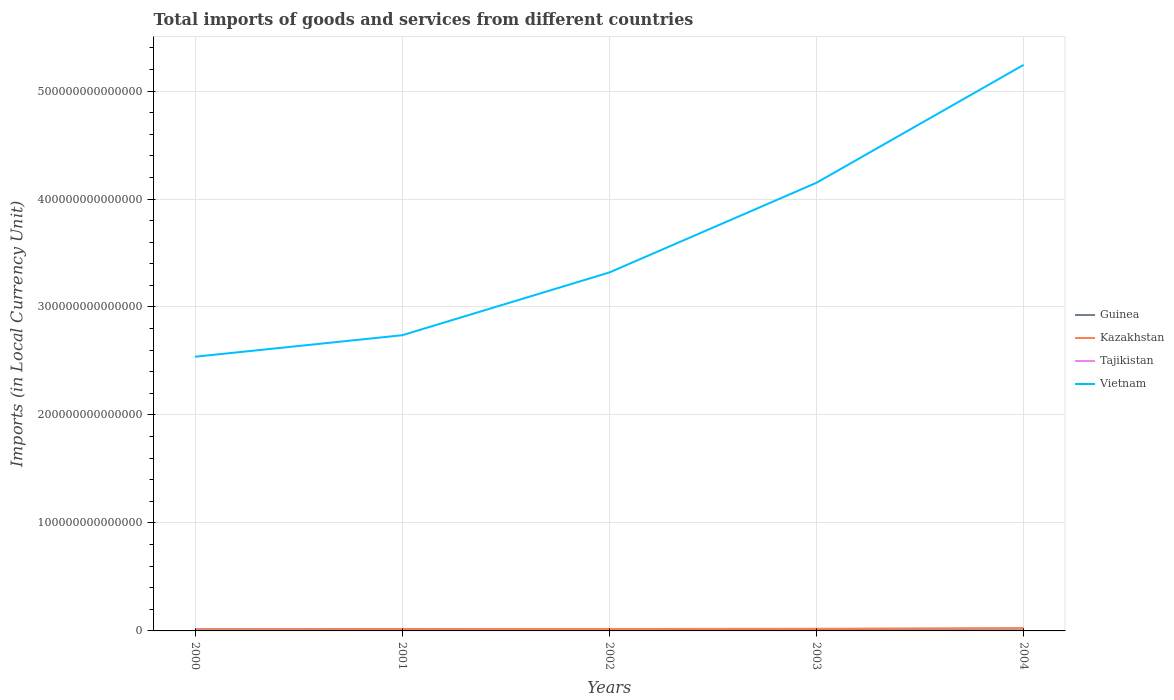How many different coloured lines are there?
Give a very brief answer. 4. Does the line corresponding to Guinea intersect with the line corresponding to Tajikistan?
Give a very brief answer. No. Is the number of lines equal to the number of legend labels?
Offer a terse response. Yes. Across all years, what is the maximum Amount of goods and services imports in Vietnam?
Provide a succinct answer. 2.54e+14. What is the total Amount of goods and services imports in Guinea in the graph?
Give a very brief answer. -4.17e+11. What is the difference between the highest and the second highest Amount of goods and services imports in Tajikistan?
Offer a terse response. 2.51e+09. What is the difference between the highest and the lowest Amount of goods and services imports in Tajikistan?
Your answer should be compact. 2. Is the Amount of goods and services imports in Kazakhstan strictly greater than the Amount of goods and services imports in Tajikistan over the years?
Your response must be concise. No. How many lines are there?
Offer a very short reply. 4. How many years are there in the graph?
Your response must be concise. 5. What is the difference between two consecutive major ticks on the Y-axis?
Keep it short and to the point. 1.00e+14. Where does the legend appear in the graph?
Offer a terse response. Center right. What is the title of the graph?
Offer a terse response. Total imports of goods and services from different countries. Does "Bulgaria" appear as one of the legend labels in the graph?
Offer a terse response. No. What is the label or title of the Y-axis?
Offer a very short reply. Imports (in Local Currency Unit). What is the Imports (in Local Currency Unit) in Guinea in 2000?
Your answer should be very brief. 1.52e+12. What is the Imports (in Local Currency Unit) in Kazakhstan in 2000?
Your answer should be compact. 1.28e+12. What is the Imports (in Local Currency Unit) of Tajikistan in 2000?
Ensure brevity in your answer.  1.80e+09. What is the Imports (in Local Currency Unit) in Vietnam in 2000?
Your response must be concise. 2.54e+14. What is the Imports (in Local Currency Unit) of Guinea in 2001?
Make the answer very short. 1.66e+12. What is the Imports (in Local Currency Unit) in Kazakhstan in 2001?
Offer a terse response. 1.53e+12. What is the Imports (in Local Currency Unit) in Tajikistan in 2001?
Your answer should be compact. 2.01e+09. What is the Imports (in Local Currency Unit) of Vietnam in 2001?
Your answer should be compact. 2.74e+14. What is the Imports (in Local Currency Unit) of Guinea in 2002?
Ensure brevity in your answer.  1.69e+12. What is the Imports (in Local Currency Unit) of Kazakhstan in 2002?
Provide a short and direct response. 1.78e+12. What is the Imports (in Local Currency Unit) in Tajikistan in 2002?
Provide a short and direct response. 2.57e+09. What is the Imports (in Local Currency Unit) of Vietnam in 2002?
Provide a short and direct response. 3.32e+14. What is the Imports (in Local Currency Unit) in Guinea in 2003?
Keep it short and to the point. 1.72e+12. What is the Imports (in Local Currency Unit) in Kazakhstan in 2003?
Offer a very short reply. 1.99e+12. What is the Imports (in Local Currency Unit) of Tajikistan in 2003?
Make the answer very short. 3.50e+09. What is the Imports (in Local Currency Unit) in Vietnam in 2003?
Offer a very short reply. 4.15e+14. What is the Imports (in Local Currency Unit) in Guinea in 2004?
Offer a terse response. 2.11e+12. What is the Imports (in Local Currency Unit) of Kazakhstan in 2004?
Keep it short and to the point. 2.58e+12. What is the Imports (in Local Currency Unit) in Tajikistan in 2004?
Give a very brief answer. 4.31e+09. What is the Imports (in Local Currency Unit) of Vietnam in 2004?
Make the answer very short. 5.24e+14. Across all years, what is the maximum Imports (in Local Currency Unit) in Guinea?
Provide a succinct answer. 2.11e+12. Across all years, what is the maximum Imports (in Local Currency Unit) in Kazakhstan?
Offer a terse response. 2.58e+12. Across all years, what is the maximum Imports (in Local Currency Unit) of Tajikistan?
Make the answer very short. 4.31e+09. Across all years, what is the maximum Imports (in Local Currency Unit) of Vietnam?
Offer a very short reply. 5.24e+14. Across all years, what is the minimum Imports (in Local Currency Unit) of Guinea?
Your answer should be compact. 1.52e+12. Across all years, what is the minimum Imports (in Local Currency Unit) in Kazakhstan?
Ensure brevity in your answer.  1.28e+12. Across all years, what is the minimum Imports (in Local Currency Unit) of Tajikistan?
Offer a terse response. 1.80e+09. Across all years, what is the minimum Imports (in Local Currency Unit) in Vietnam?
Offer a terse response. 2.54e+14. What is the total Imports (in Local Currency Unit) in Guinea in the graph?
Your answer should be compact. 8.69e+12. What is the total Imports (in Local Currency Unit) in Kazakhstan in the graph?
Give a very brief answer. 9.14e+12. What is the total Imports (in Local Currency Unit) of Tajikistan in the graph?
Offer a terse response. 1.42e+1. What is the total Imports (in Local Currency Unit) in Vietnam in the graph?
Offer a very short reply. 1.80e+15. What is the difference between the Imports (in Local Currency Unit) in Guinea in 2000 and that in 2001?
Your answer should be compact. -1.41e+11. What is the difference between the Imports (in Local Currency Unit) in Kazakhstan in 2000 and that in 2001?
Offer a very short reply. -2.50e+11. What is the difference between the Imports (in Local Currency Unit) of Tajikistan in 2000 and that in 2001?
Your answer should be compact. -2.06e+08. What is the difference between the Imports (in Local Currency Unit) of Vietnam in 2000 and that in 2001?
Offer a terse response. -1.99e+13. What is the difference between the Imports (in Local Currency Unit) of Guinea in 2000 and that in 2002?
Make the answer very short. -1.74e+11. What is the difference between the Imports (in Local Currency Unit) of Kazakhstan in 2000 and that in 2002?
Offer a very short reply. -5.00e+11. What is the difference between the Imports (in Local Currency Unit) of Tajikistan in 2000 and that in 2002?
Make the answer very short. -7.65e+08. What is the difference between the Imports (in Local Currency Unit) of Vietnam in 2000 and that in 2002?
Offer a terse response. -7.80e+13. What is the difference between the Imports (in Local Currency Unit) of Guinea in 2000 and that in 2003?
Offer a terse response. -2.08e+11. What is the difference between the Imports (in Local Currency Unit) in Kazakhstan in 2000 and that in 2003?
Give a very brief answer. -7.09e+11. What is the difference between the Imports (in Local Currency Unit) in Tajikistan in 2000 and that in 2003?
Keep it short and to the point. -1.69e+09. What is the difference between the Imports (in Local Currency Unit) of Vietnam in 2000 and that in 2003?
Keep it short and to the point. -1.61e+14. What is the difference between the Imports (in Local Currency Unit) of Guinea in 2000 and that in 2004?
Provide a short and direct response. -5.91e+11. What is the difference between the Imports (in Local Currency Unit) in Kazakhstan in 2000 and that in 2004?
Your answer should be very brief. -1.30e+12. What is the difference between the Imports (in Local Currency Unit) of Tajikistan in 2000 and that in 2004?
Make the answer very short. -2.51e+09. What is the difference between the Imports (in Local Currency Unit) of Vietnam in 2000 and that in 2004?
Make the answer very short. -2.70e+14. What is the difference between the Imports (in Local Currency Unit) of Guinea in 2001 and that in 2002?
Provide a succinct answer. -3.20e+1. What is the difference between the Imports (in Local Currency Unit) of Kazakhstan in 2001 and that in 2002?
Keep it short and to the point. -2.50e+11. What is the difference between the Imports (in Local Currency Unit) in Tajikistan in 2001 and that in 2002?
Your response must be concise. -5.59e+08. What is the difference between the Imports (in Local Currency Unit) in Vietnam in 2001 and that in 2002?
Offer a terse response. -5.81e+13. What is the difference between the Imports (in Local Currency Unit) in Guinea in 2001 and that in 2003?
Keep it short and to the point. -6.62e+1. What is the difference between the Imports (in Local Currency Unit) of Kazakhstan in 2001 and that in 2003?
Ensure brevity in your answer.  -4.59e+11. What is the difference between the Imports (in Local Currency Unit) in Tajikistan in 2001 and that in 2003?
Your answer should be very brief. -1.49e+09. What is the difference between the Imports (in Local Currency Unit) of Vietnam in 2001 and that in 2003?
Make the answer very short. -1.41e+14. What is the difference between the Imports (in Local Currency Unit) of Guinea in 2001 and that in 2004?
Keep it short and to the point. -4.49e+11. What is the difference between the Imports (in Local Currency Unit) of Kazakhstan in 2001 and that in 2004?
Your answer should be compact. -1.05e+12. What is the difference between the Imports (in Local Currency Unit) in Tajikistan in 2001 and that in 2004?
Give a very brief answer. -2.30e+09. What is the difference between the Imports (in Local Currency Unit) in Vietnam in 2001 and that in 2004?
Provide a succinct answer. -2.50e+14. What is the difference between the Imports (in Local Currency Unit) of Guinea in 2002 and that in 2003?
Offer a terse response. -3.42e+1. What is the difference between the Imports (in Local Currency Unit) in Kazakhstan in 2002 and that in 2003?
Ensure brevity in your answer.  -2.09e+11. What is the difference between the Imports (in Local Currency Unit) of Tajikistan in 2002 and that in 2003?
Give a very brief answer. -9.28e+08. What is the difference between the Imports (in Local Currency Unit) of Vietnam in 2002 and that in 2003?
Your answer should be very brief. -8.31e+13. What is the difference between the Imports (in Local Currency Unit) in Guinea in 2002 and that in 2004?
Provide a short and direct response. -4.17e+11. What is the difference between the Imports (in Local Currency Unit) in Kazakhstan in 2002 and that in 2004?
Provide a short and direct response. -8.01e+11. What is the difference between the Imports (in Local Currency Unit) in Tajikistan in 2002 and that in 2004?
Make the answer very short. -1.74e+09. What is the difference between the Imports (in Local Currency Unit) of Vietnam in 2002 and that in 2004?
Ensure brevity in your answer.  -1.92e+14. What is the difference between the Imports (in Local Currency Unit) of Guinea in 2003 and that in 2004?
Offer a terse response. -3.83e+11. What is the difference between the Imports (in Local Currency Unit) in Kazakhstan in 2003 and that in 2004?
Offer a terse response. -5.92e+11. What is the difference between the Imports (in Local Currency Unit) of Tajikistan in 2003 and that in 2004?
Ensure brevity in your answer.  -8.15e+08. What is the difference between the Imports (in Local Currency Unit) in Vietnam in 2003 and that in 2004?
Provide a succinct answer. -1.09e+14. What is the difference between the Imports (in Local Currency Unit) of Guinea in 2000 and the Imports (in Local Currency Unit) of Kazakhstan in 2001?
Your answer should be very brief. -1.11e+1. What is the difference between the Imports (in Local Currency Unit) of Guinea in 2000 and the Imports (in Local Currency Unit) of Tajikistan in 2001?
Provide a succinct answer. 1.51e+12. What is the difference between the Imports (in Local Currency Unit) in Guinea in 2000 and the Imports (in Local Currency Unit) in Vietnam in 2001?
Give a very brief answer. -2.72e+14. What is the difference between the Imports (in Local Currency Unit) in Kazakhstan in 2000 and the Imports (in Local Currency Unit) in Tajikistan in 2001?
Ensure brevity in your answer.  1.27e+12. What is the difference between the Imports (in Local Currency Unit) of Kazakhstan in 2000 and the Imports (in Local Currency Unit) of Vietnam in 2001?
Provide a short and direct response. -2.73e+14. What is the difference between the Imports (in Local Currency Unit) of Tajikistan in 2000 and the Imports (in Local Currency Unit) of Vietnam in 2001?
Give a very brief answer. -2.74e+14. What is the difference between the Imports (in Local Currency Unit) of Guinea in 2000 and the Imports (in Local Currency Unit) of Kazakhstan in 2002?
Your answer should be very brief. -2.61e+11. What is the difference between the Imports (in Local Currency Unit) of Guinea in 2000 and the Imports (in Local Currency Unit) of Tajikistan in 2002?
Your response must be concise. 1.51e+12. What is the difference between the Imports (in Local Currency Unit) in Guinea in 2000 and the Imports (in Local Currency Unit) in Vietnam in 2002?
Make the answer very short. -3.30e+14. What is the difference between the Imports (in Local Currency Unit) in Kazakhstan in 2000 and the Imports (in Local Currency Unit) in Tajikistan in 2002?
Keep it short and to the point. 1.27e+12. What is the difference between the Imports (in Local Currency Unit) in Kazakhstan in 2000 and the Imports (in Local Currency Unit) in Vietnam in 2002?
Give a very brief answer. -3.31e+14. What is the difference between the Imports (in Local Currency Unit) of Tajikistan in 2000 and the Imports (in Local Currency Unit) of Vietnam in 2002?
Provide a short and direct response. -3.32e+14. What is the difference between the Imports (in Local Currency Unit) of Guinea in 2000 and the Imports (in Local Currency Unit) of Kazakhstan in 2003?
Your answer should be very brief. -4.70e+11. What is the difference between the Imports (in Local Currency Unit) of Guinea in 2000 and the Imports (in Local Currency Unit) of Tajikistan in 2003?
Provide a short and direct response. 1.51e+12. What is the difference between the Imports (in Local Currency Unit) in Guinea in 2000 and the Imports (in Local Currency Unit) in Vietnam in 2003?
Ensure brevity in your answer.  -4.14e+14. What is the difference between the Imports (in Local Currency Unit) of Kazakhstan in 2000 and the Imports (in Local Currency Unit) of Tajikistan in 2003?
Your answer should be compact. 1.27e+12. What is the difference between the Imports (in Local Currency Unit) of Kazakhstan in 2000 and the Imports (in Local Currency Unit) of Vietnam in 2003?
Ensure brevity in your answer.  -4.14e+14. What is the difference between the Imports (in Local Currency Unit) of Tajikistan in 2000 and the Imports (in Local Currency Unit) of Vietnam in 2003?
Provide a short and direct response. -4.15e+14. What is the difference between the Imports (in Local Currency Unit) of Guinea in 2000 and the Imports (in Local Currency Unit) of Kazakhstan in 2004?
Make the answer very short. -1.06e+12. What is the difference between the Imports (in Local Currency Unit) in Guinea in 2000 and the Imports (in Local Currency Unit) in Tajikistan in 2004?
Your response must be concise. 1.51e+12. What is the difference between the Imports (in Local Currency Unit) in Guinea in 2000 and the Imports (in Local Currency Unit) in Vietnam in 2004?
Provide a succinct answer. -5.23e+14. What is the difference between the Imports (in Local Currency Unit) of Kazakhstan in 2000 and the Imports (in Local Currency Unit) of Tajikistan in 2004?
Ensure brevity in your answer.  1.27e+12. What is the difference between the Imports (in Local Currency Unit) in Kazakhstan in 2000 and the Imports (in Local Currency Unit) in Vietnam in 2004?
Your answer should be compact. -5.23e+14. What is the difference between the Imports (in Local Currency Unit) of Tajikistan in 2000 and the Imports (in Local Currency Unit) of Vietnam in 2004?
Provide a succinct answer. -5.24e+14. What is the difference between the Imports (in Local Currency Unit) of Guinea in 2001 and the Imports (in Local Currency Unit) of Kazakhstan in 2002?
Offer a very short reply. -1.20e+11. What is the difference between the Imports (in Local Currency Unit) in Guinea in 2001 and the Imports (in Local Currency Unit) in Tajikistan in 2002?
Provide a succinct answer. 1.65e+12. What is the difference between the Imports (in Local Currency Unit) of Guinea in 2001 and the Imports (in Local Currency Unit) of Vietnam in 2002?
Offer a very short reply. -3.30e+14. What is the difference between the Imports (in Local Currency Unit) of Kazakhstan in 2001 and the Imports (in Local Currency Unit) of Tajikistan in 2002?
Provide a succinct answer. 1.52e+12. What is the difference between the Imports (in Local Currency Unit) of Kazakhstan in 2001 and the Imports (in Local Currency Unit) of Vietnam in 2002?
Offer a very short reply. -3.30e+14. What is the difference between the Imports (in Local Currency Unit) in Tajikistan in 2001 and the Imports (in Local Currency Unit) in Vietnam in 2002?
Offer a terse response. -3.32e+14. What is the difference between the Imports (in Local Currency Unit) of Guinea in 2001 and the Imports (in Local Currency Unit) of Kazakhstan in 2003?
Your answer should be very brief. -3.29e+11. What is the difference between the Imports (in Local Currency Unit) of Guinea in 2001 and the Imports (in Local Currency Unit) of Tajikistan in 2003?
Your answer should be compact. 1.65e+12. What is the difference between the Imports (in Local Currency Unit) in Guinea in 2001 and the Imports (in Local Currency Unit) in Vietnam in 2003?
Ensure brevity in your answer.  -4.13e+14. What is the difference between the Imports (in Local Currency Unit) of Kazakhstan in 2001 and the Imports (in Local Currency Unit) of Tajikistan in 2003?
Offer a very short reply. 1.52e+12. What is the difference between the Imports (in Local Currency Unit) in Kazakhstan in 2001 and the Imports (in Local Currency Unit) in Vietnam in 2003?
Offer a terse response. -4.13e+14. What is the difference between the Imports (in Local Currency Unit) of Tajikistan in 2001 and the Imports (in Local Currency Unit) of Vietnam in 2003?
Offer a very short reply. -4.15e+14. What is the difference between the Imports (in Local Currency Unit) of Guinea in 2001 and the Imports (in Local Currency Unit) of Kazakhstan in 2004?
Keep it short and to the point. -9.21e+11. What is the difference between the Imports (in Local Currency Unit) of Guinea in 2001 and the Imports (in Local Currency Unit) of Tajikistan in 2004?
Make the answer very short. 1.65e+12. What is the difference between the Imports (in Local Currency Unit) of Guinea in 2001 and the Imports (in Local Currency Unit) of Vietnam in 2004?
Offer a very short reply. -5.23e+14. What is the difference between the Imports (in Local Currency Unit) of Kazakhstan in 2001 and the Imports (in Local Currency Unit) of Tajikistan in 2004?
Your answer should be very brief. 1.52e+12. What is the difference between the Imports (in Local Currency Unit) in Kazakhstan in 2001 and the Imports (in Local Currency Unit) in Vietnam in 2004?
Your response must be concise. -5.23e+14. What is the difference between the Imports (in Local Currency Unit) in Tajikistan in 2001 and the Imports (in Local Currency Unit) in Vietnam in 2004?
Your response must be concise. -5.24e+14. What is the difference between the Imports (in Local Currency Unit) in Guinea in 2002 and the Imports (in Local Currency Unit) in Kazakhstan in 2003?
Your answer should be compact. -2.97e+11. What is the difference between the Imports (in Local Currency Unit) in Guinea in 2002 and the Imports (in Local Currency Unit) in Tajikistan in 2003?
Give a very brief answer. 1.69e+12. What is the difference between the Imports (in Local Currency Unit) in Guinea in 2002 and the Imports (in Local Currency Unit) in Vietnam in 2003?
Keep it short and to the point. -4.13e+14. What is the difference between the Imports (in Local Currency Unit) in Kazakhstan in 2002 and the Imports (in Local Currency Unit) in Tajikistan in 2003?
Give a very brief answer. 1.77e+12. What is the difference between the Imports (in Local Currency Unit) of Kazakhstan in 2002 and the Imports (in Local Currency Unit) of Vietnam in 2003?
Keep it short and to the point. -4.13e+14. What is the difference between the Imports (in Local Currency Unit) of Tajikistan in 2002 and the Imports (in Local Currency Unit) of Vietnam in 2003?
Ensure brevity in your answer.  -4.15e+14. What is the difference between the Imports (in Local Currency Unit) of Guinea in 2002 and the Imports (in Local Currency Unit) of Kazakhstan in 2004?
Your answer should be very brief. -8.89e+11. What is the difference between the Imports (in Local Currency Unit) of Guinea in 2002 and the Imports (in Local Currency Unit) of Tajikistan in 2004?
Provide a succinct answer. 1.68e+12. What is the difference between the Imports (in Local Currency Unit) of Guinea in 2002 and the Imports (in Local Currency Unit) of Vietnam in 2004?
Keep it short and to the point. -5.23e+14. What is the difference between the Imports (in Local Currency Unit) in Kazakhstan in 2002 and the Imports (in Local Currency Unit) in Tajikistan in 2004?
Give a very brief answer. 1.77e+12. What is the difference between the Imports (in Local Currency Unit) of Kazakhstan in 2002 and the Imports (in Local Currency Unit) of Vietnam in 2004?
Your response must be concise. -5.22e+14. What is the difference between the Imports (in Local Currency Unit) of Tajikistan in 2002 and the Imports (in Local Currency Unit) of Vietnam in 2004?
Make the answer very short. -5.24e+14. What is the difference between the Imports (in Local Currency Unit) in Guinea in 2003 and the Imports (in Local Currency Unit) in Kazakhstan in 2004?
Offer a terse response. -8.55e+11. What is the difference between the Imports (in Local Currency Unit) in Guinea in 2003 and the Imports (in Local Currency Unit) in Tajikistan in 2004?
Your answer should be compact. 1.72e+12. What is the difference between the Imports (in Local Currency Unit) of Guinea in 2003 and the Imports (in Local Currency Unit) of Vietnam in 2004?
Ensure brevity in your answer.  -5.22e+14. What is the difference between the Imports (in Local Currency Unit) in Kazakhstan in 2003 and the Imports (in Local Currency Unit) in Tajikistan in 2004?
Offer a very short reply. 1.98e+12. What is the difference between the Imports (in Local Currency Unit) in Kazakhstan in 2003 and the Imports (in Local Currency Unit) in Vietnam in 2004?
Provide a succinct answer. -5.22e+14. What is the difference between the Imports (in Local Currency Unit) of Tajikistan in 2003 and the Imports (in Local Currency Unit) of Vietnam in 2004?
Ensure brevity in your answer.  -5.24e+14. What is the average Imports (in Local Currency Unit) in Guinea per year?
Your response must be concise. 1.74e+12. What is the average Imports (in Local Currency Unit) in Kazakhstan per year?
Give a very brief answer. 1.83e+12. What is the average Imports (in Local Currency Unit) of Tajikistan per year?
Ensure brevity in your answer.  2.84e+09. What is the average Imports (in Local Currency Unit) of Vietnam per year?
Keep it short and to the point. 3.60e+14. In the year 2000, what is the difference between the Imports (in Local Currency Unit) in Guinea and Imports (in Local Currency Unit) in Kazakhstan?
Provide a succinct answer. 2.39e+11. In the year 2000, what is the difference between the Imports (in Local Currency Unit) in Guinea and Imports (in Local Currency Unit) in Tajikistan?
Offer a terse response. 1.51e+12. In the year 2000, what is the difference between the Imports (in Local Currency Unit) of Guinea and Imports (in Local Currency Unit) of Vietnam?
Your answer should be very brief. -2.52e+14. In the year 2000, what is the difference between the Imports (in Local Currency Unit) in Kazakhstan and Imports (in Local Currency Unit) in Tajikistan?
Your answer should be very brief. 1.27e+12. In the year 2000, what is the difference between the Imports (in Local Currency Unit) of Kazakhstan and Imports (in Local Currency Unit) of Vietnam?
Your answer should be very brief. -2.53e+14. In the year 2000, what is the difference between the Imports (in Local Currency Unit) of Tajikistan and Imports (in Local Currency Unit) of Vietnam?
Offer a very short reply. -2.54e+14. In the year 2001, what is the difference between the Imports (in Local Currency Unit) of Guinea and Imports (in Local Currency Unit) of Kazakhstan?
Provide a succinct answer. 1.30e+11. In the year 2001, what is the difference between the Imports (in Local Currency Unit) in Guinea and Imports (in Local Currency Unit) in Tajikistan?
Offer a terse response. 1.65e+12. In the year 2001, what is the difference between the Imports (in Local Currency Unit) in Guinea and Imports (in Local Currency Unit) in Vietnam?
Offer a terse response. -2.72e+14. In the year 2001, what is the difference between the Imports (in Local Currency Unit) in Kazakhstan and Imports (in Local Currency Unit) in Tajikistan?
Keep it short and to the point. 1.52e+12. In the year 2001, what is the difference between the Imports (in Local Currency Unit) in Kazakhstan and Imports (in Local Currency Unit) in Vietnam?
Your answer should be compact. -2.72e+14. In the year 2001, what is the difference between the Imports (in Local Currency Unit) in Tajikistan and Imports (in Local Currency Unit) in Vietnam?
Make the answer very short. -2.74e+14. In the year 2002, what is the difference between the Imports (in Local Currency Unit) in Guinea and Imports (in Local Currency Unit) in Kazakhstan?
Keep it short and to the point. -8.77e+1. In the year 2002, what is the difference between the Imports (in Local Currency Unit) of Guinea and Imports (in Local Currency Unit) of Tajikistan?
Offer a very short reply. 1.69e+12. In the year 2002, what is the difference between the Imports (in Local Currency Unit) of Guinea and Imports (in Local Currency Unit) of Vietnam?
Keep it short and to the point. -3.30e+14. In the year 2002, what is the difference between the Imports (in Local Currency Unit) of Kazakhstan and Imports (in Local Currency Unit) of Tajikistan?
Your answer should be compact. 1.77e+12. In the year 2002, what is the difference between the Imports (in Local Currency Unit) of Kazakhstan and Imports (in Local Currency Unit) of Vietnam?
Make the answer very short. -3.30e+14. In the year 2002, what is the difference between the Imports (in Local Currency Unit) of Tajikistan and Imports (in Local Currency Unit) of Vietnam?
Give a very brief answer. -3.32e+14. In the year 2003, what is the difference between the Imports (in Local Currency Unit) in Guinea and Imports (in Local Currency Unit) in Kazakhstan?
Your response must be concise. -2.62e+11. In the year 2003, what is the difference between the Imports (in Local Currency Unit) of Guinea and Imports (in Local Currency Unit) of Tajikistan?
Provide a short and direct response. 1.72e+12. In the year 2003, what is the difference between the Imports (in Local Currency Unit) of Guinea and Imports (in Local Currency Unit) of Vietnam?
Provide a succinct answer. -4.13e+14. In the year 2003, what is the difference between the Imports (in Local Currency Unit) of Kazakhstan and Imports (in Local Currency Unit) of Tajikistan?
Give a very brief answer. 1.98e+12. In the year 2003, what is the difference between the Imports (in Local Currency Unit) of Kazakhstan and Imports (in Local Currency Unit) of Vietnam?
Provide a short and direct response. -4.13e+14. In the year 2003, what is the difference between the Imports (in Local Currency Unit) in Tajikistan and Imports (in Local Currency Unit) in Vietnam?
Provide a short and direct response. -4.15e+14. In the year 2004, what is the difference between the Imports (in Local Currency Unit) in Guinea and Imports (in Local Currency Unit) in Kazakhstan?
Provide a succinct answer. -4.71e+11. In the year 2004, what is the difference between the Imports (in Local Currency Unit) in Guinea and Imports (in Local Currency Unit) in Tajikistan?
Give a very brief answer. 2.10e+12. In the year 2004, what is the difference between the Imports (in Local Currency Unit) in Guinea and Imports (in Local Currency Unit) in Vietnam?
Offer a terse response. -5.22e+14. In the year 2004, what is the difference between the Imports (in Local Currency Unit) in Kazakhstan and Imports (in Local Currency Unit) in Tajikistan?
Your answer should be compact. 2.57e+12. In the year 2004, what is the difference between the Imports (in Local Currency Unit) of Kazakhstan and Imports (in Local Currency Unit) of Vietnam?
Provide a short and direct response. -5.22e+14. In the year 2004, what is the difference between the Imports (in Local Currency Unit) of Tajikistan and Imports (in Local Currency Unit) of Vietnam?
Provide a succinct answer. -5.24e+14. What is the ratio of the Imports (in Local Currency Unit) in Guinea in 2000 to that in 2001?
Offer a very short reply. 0.91. What is the ratio of the Imports (in Local Currency Unit) in Kazakhstan in 2000 to that in 2001?
Offer a terse response. 0.84. What is the ratio of the Imports (in Local Currency Unit) of Tajikistan in 2000 to that in 2001?
Provide a succinct answer. 0.9. What is the ratio of the Imports (in Local Currency Unit) in Vietnam in 2000 to that in 2001?
Provide a short and direct response. 0.93. What is the ratio of the Imports (in Local Currency Unit) in Guinea in 2000 to that in 2002?
Make the answer very short. 0.9. What is the ratio of the Imports (in Local Currency Unit) in Kazakhstan in 2000 to that in 2002?
Ensure brevity in your answer.  0.72. What is the ratio of the Imports (in Local Currency Unit) in Tajikistan in 2000 to that in 2002?
Your answer should be very brief. 0.7. What is the ratio of the Imports (in Local Currency Unit) in Vietnam in 2000 to that in 2002?
Provide a succinct answer. 0.77. What is the ratio of the Imports (in Local Currency Unit) in Guinea in 2000 to that in 2003?
Offer a terse response. 0.88. What is the ratio of the Imports (in Local Currency Unit) in Kazakhstan in 2000 to that in 2003?
Provide a succinct answer. 0.64. What is the ratio of the Imports (in Local Currency Unit) of Tajikistan in 2000 to that in 2003?
Make the answer very short. 0.52. What is the ratio of the Imports (in Local Currency Unit) in Vietnam in 2000 to that in 2003?
Your answer should be very brief. 0.61. What is the ratio of the Imports (in Local Currency Unit) of Guinea in 2000 to that in 2004?
Make the answer very short. 0.72. What is the ratio of the Imports (in Local Currency Unit) in Kazakhstan in 2000 to that in 2004?
Keep it short and to the point. 0.5. What is the ratio of the Imports (in Local Currency Unit) in Tajikistan in 2000 to that in 2004?
Your answer should be very brief. 0.42. What is the ratio of the Imports (in Local Currency Unit) of Vietnam in 2000 to that in 2004?
Offer a terse response. 0.48. What is the ratio of the Imports (in Local Currency Unit) of Kazakhstan in 2001 to that in 2002?
Your response must be concise. 0.86. What is the ratio of the Imports (in Local Currency Unit) of Tajikistan in 2001 to that in 2002?
Make the answer very short. 0.78. What is the ratio of the Imports (in Local Currency Unit) in Vietnam in 2001 to that in 2002?
Offer a very short reply. 0.82. What is the ratio of the Imports (in Local Currency Unit) in Guinea in 2001 to that in 2003?
Your answer should be very brief. 0.96. What is the ratio of the Imports (in Local Currency Unit) in Kazakhstan in 2001 to that in 2003?
Offer a very short reply. 0.77. What is the ratio of the Imports (in Local Currency Unit) of Tajikistan in 2001 to that in 2003?
Offer a terse response. 0.57. What is the ratio of the Imports (in Local Currency Unit) in Vietnam in 2001 to that in 2003?
Keep it short and to the point. 0.66. What is the ratio of the Imports (in Local Currency Unit) of Guinea in 2001 to that in 2004?
Make the answer very short. 0.79. What is the ratio of the Imports (in Local Currency Unit) of Kazakhstan in 2001 to that in 2004?
Keep it short and to the point. 0.59. What is the ratio of the Imports (in Local Currency Unit) in Tajikistan in 2001 to that in 2004?
Give a very brief answer. 0.47. What is the ratio of the Imports (in Local Currency Unit) of Vietnam in 2001 to that in 2004?
Provide a short and direct response. 0.52. What is the ratio of the Imports (in Local Currency Unit) in Guinea in 2002 to that in 2003?
Provide a short and direct response. 0.98. What is the ratio of the Imports (in Local Currency Unit) in Kazakhstan in 2002 to that in 2003?
Your answer should be compact. 0.89. What is the ratio of the Imports (in Local Currency Unit) of Tajikistan in 2002 to that in 2003?
Offer a very short reply. 0.73. What is the ratio of the Imports (in Local Currency Unit) of Vietnam in 2002 to that in 2003?
Provide a succinct answer. 0.8. What is the ratio of the Imports (in Local Currency Unit) of Guinea in 2002 to that in 2004?
Your answer should be compact. 0.8. What is the ratio of the Imports (in Local Currency Unit) of Kazakhstan in 2002 to that in 2004?
Offer a very short reply. 0.69. What is the ratio of the Imports (in Local Currency Unit) of Tajikistan in 2002 to that in 2004?
Provide a short and direct response. 0.6. What is the ratio of the Imports (in Local Currency Unit) in Vietnam in 2002 to that in 2004?
Offer a terse response. 0.63. What is the ratio of the Imports (in Local Currency Unit) in Guinea in 2003 to that in 2004?
Your answer should be compact. 0.82. What is the ratio of the Imports (in Local Currency Unit) of Kazakhstan in 2003 to that in 2004?
Your response must be concise. 0.77. What is the ratio of the Imports (in Local Currency Unit) of Tajikistan in 2003 to that in 2004?
Give a very brief answer. 0.81. What is the ratio of the Imports (in Local Currency Unit) in Vietnam in 2003 to that in 2004?
Offer a very short reply. 0.79. What is the difference between the highest and the second highest Imports (in Local Currency Unit) in Guinea?
Provide a short and direct response. 3.83e+11. What is the difference between the highest and the second highest Imports (in Local Currency Unit) of Kazakhstan?
Make the answer very short. 5.92e+11. What is the difference between the highest and the second highest Imports (in Local Currency Unit) of Tajikistan?
Your answer should be compact. 8.15e+08. What is the difference between the highest and the second highest Imports (in Local Currency Unit) of Vietnam?
Provide a succinct answer. 1.09e+14. What is the difference between the highest and the lowest Imports (in Local Currency Unit) of Guinea?
Give a very brief answer. 5.91e+11. What is the difference between the highest and the lowest Imports (in Local Currency Unit) in Kazakhstan?
Provide a short and direct response. 1.30e+12. What is the difference between the highest and the lowest Imports (in Local Currency Unit) in Tajikistan?
Provide a succinct answer. 2.51e+09. What is the difference between the highest and the lowest Imports (in Local Currency Unit) in Vietnam?
Give a very brief answer. 2.70e+14. 